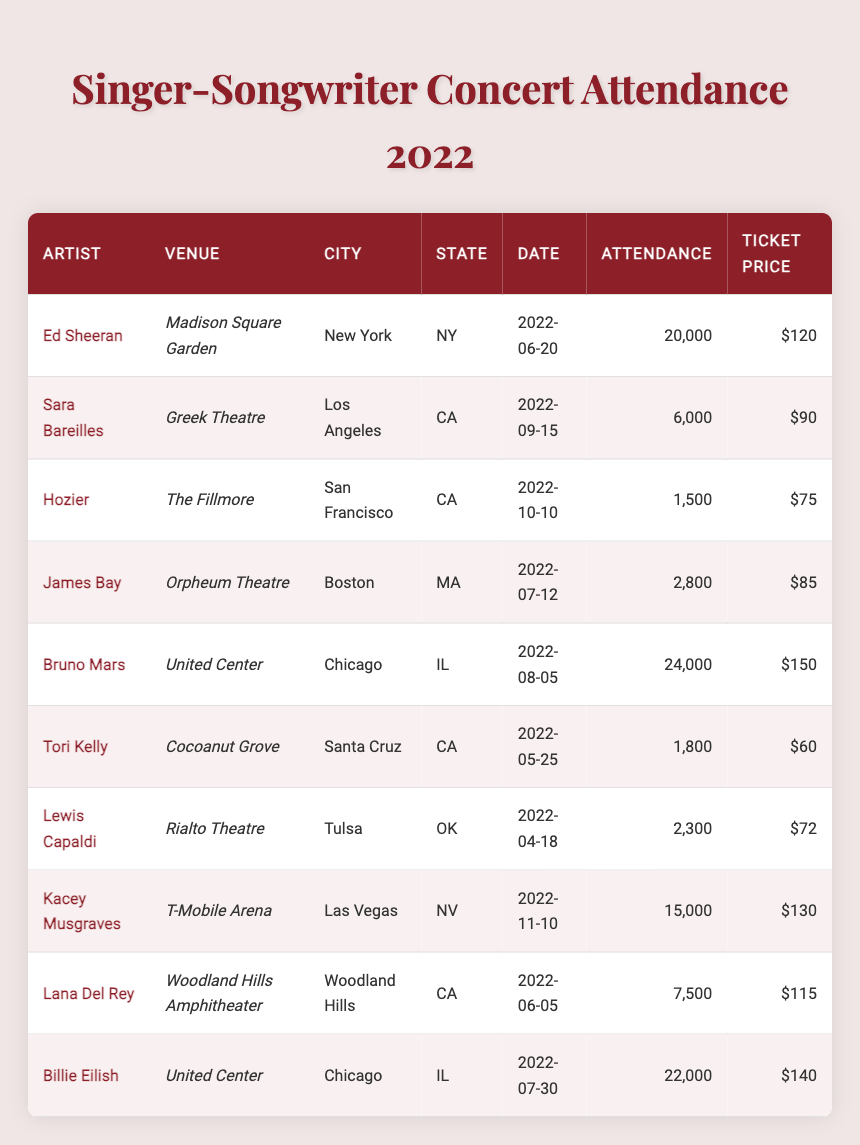What is the total attendance for Ed Sheeran's concert? Ed Sheeran's concert at Madison Square Garden had an attendance of 20,000. This value can be directly found under the "Attendance" column in his corresponding row.
Answer: 20,000 Who had the lowest ticket price among the artists listed? Tori Kelly had the lowest ticket price at $60, according to the "Ticket Price" column. Comparing the ticket prices across all artists, Tori Kelly's price is the minimum.
Answer: $60 What was the average ticket price for the concerts held in Chicago? The ticket prices for concerts in Chicago were $150 (Bruno Mars) and $140 (Billie Eilish). The average is calculated as (150 + 140) / 2 = 145.
Answer: $145 Is the attendance for Kacey Musgraves' concert greater than 10,000? Kacey Musgraves had an attendance of 15,000. Since 15,000 is greater than 10,000, the answer is true.
Answer: Yes Which artist had a concert with attendance higher than 20,000? The concerts by Bruno Mars (24,000) and Billie Eilish (22,000) both had attendance figures higher than 20,000. This is verified by looking at their respective attendance values in the table.
Answer: Bruno Mars, Billie Eilish What is the total attendance across all concerts held in California? The concerts in California are by Sara Bareilles (6,000), Hozier (1,500), Tori Kelly (1,800), and Lana Del Rey (7,500). Adding these up gives us a total of 6,000 + 1,500 + 1,800 + 7,500 = 16,800.
Answer: 16,800 Did any artist perform at a venue with an attendance of exactly 1,500? Yes, Hozier performed at The Fillmore with an attendance of exactly 1,500. This is confirmed by finding the row for Hozier and checking his attendance value.
Answer: Yes What date did Billie Eilish perform? Billie Eilish performed on July 30, 2022, as stated in the "Date" column of her respective entry in the table.
Answer: July 30, 2022 How many concerts in total were held in New York? There was only one concert held in New York, which was Ed Sheeran's concert at Madison Square Garden. This can be verified by checking the "City" column for the city name New York.
Answer: 1 